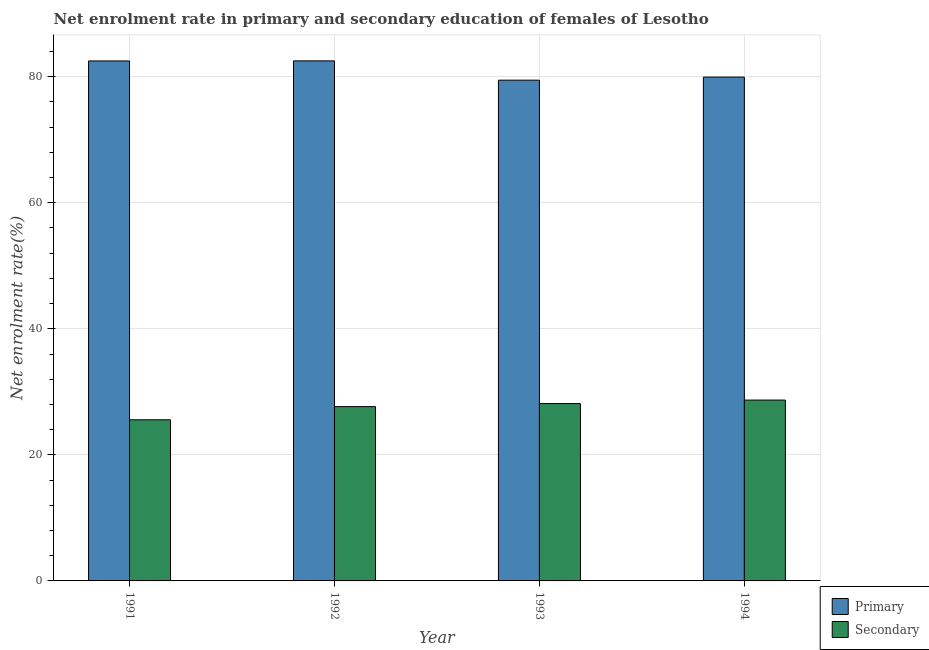How many different coloured bars are there?
Make the answer very short. 2. Are the number of bars per tick equal to the number of legend labels?
Give a very brief answer. Yes. What is the label of the 1st group of bars from the left?
Offer a very short reply. 1991. What is the enrollment rate in primary education in 1992?
Offer a very short reply. 82.52. Across all years, what is the maximum enrollment rate in primary education?
Your response must be concise. 82.52. Across all years, what is the minimum enrollment rate in secondary education?
Offer a very short reply. 25.57. In which year was the enrollment rate in secondary education maximum?
Ensure brevity in your answer.  1994. In which year was the enrollment rate in secondary education minimum?
Ensure brevity in your answer.  1991. What is the total enrollment rate in secondary education in the graph?
Your answer should be compact. 110.06. What is the difference between the enrollment rate in secondary education in 1991 and that in 1993?
Offer a terse response. -2.57. What is the difference between the enrollment rate in primary education in 1991 and the enrollment rate in secondary education in 1992?
Give a very brief answer. -0.01. What is the average enrollment rate in secondary education per year?
Offer a terse response. 27.51. In the year 1994, what is the difference between the enrollment rate in secondary education and enrollment rate in primary education?
Make the answer very short. 0. What is the ratio of the enrollment rate in secondary education in 1992 to that in 1993?
Ensure brevity in your answer.  0.98. Is the enrollment rate in secondary education in 1992 less than that in 1994?
Provide a short and direct response. Yes. Is the difference between the enrollment rate in primary education in 1993 and 1994 greater than the difference between the enrollment rate in secondary education in 1993 and 1994?
Your answer should be very brief. No. What is the difference between the highest and the second highest enrollment rate in secondary education?
Ensure brevity in your answer.  0.56. What is the difference between the highest and the lowest enrollment rate in primary education?
Give a very brief answer. 3.06. In how many years, is the enrollment rate in secondary education greater than the average enrollment rate in secondary education taken over all years?
Provide a short and direct response. 3. What does the 2nd bar from the left in 1993 represents?
Offer a terse response. Secondary. What does the 1st bar from the right in 1991 represents?
Provide a succinct answer. Secondary. How many bars are there?
Provide a short and direct response. 8. Are all the bars in the graph horizontal?
Offer a very short reply. No. How many years are there in the graph?
Provide a succinct answer. 4. What is the difference between two consecutive major ticks on the Y-axis?
Offer a very short reply. 20. Are the values on the major ticks of Y-axis written in scientific E-notation?
Your response must be concise. No. How many legend labels are there?
Provide a short and direct response. 2. How are the legend labels stacked?
Provide a short and direct response. Vertical. What is the title of the graph?
Ensure brevity in your answer.  Net enrolment rate in primary and secondary education of females of Lesotho. Does "Export" appear as one of the legend labels in the graph?
Offer a terse response. No. What is the label or title of the Y-axis?
Provide a short and direct response. Net enrolment rate(%). What is the Net enrolment rate(%) in Primary in 1991?
Provide a short and direct response. 82.51. What is the Net enrolment rate(%) of Secondary in 1991?
Make the answer very short. 25.57. What is the Net enrolment rate(%) of Primary in 1992?
Offer a terse response. 82.52. What is the Net enrolment rate(%) in Secondary in 1992?
Make the answer very short. 27.66. What is the Net enrolment rate(%) of Primary in 1993?
Provide a succinct answer. 79.46. What is the Net enrolment rate(%) of Secondary in 1993?
Provide a short and direct response. 28.14. What is the Net enrolment rate(%) of Primary in 1994?
Provide a succinct answer. 79.94. What is the Net enrolment rate(%) in Secondary in 1994?
Give a very brief answer. 28.7. Across all years, what is the maximum Net enrolment rate(%) of Primary?
Offer a terse response. 82.52. Across all years, what is the maximum Net enrolment rate(%) of Secondary?
Provide a short and direct response. 28.7. Across all years, what is the minimum Net enrolment rate(%) in Primary?
Provide a succinct answer. 79.46. Across all years, what is the minimum Net enrolment rate(%) in Secondary?
Offer a terse response. 25.57. What is the total Net enrolment rate(%) in Primary in the graph?
Provide a short and direct response. 324.42. What is the total Net enrolment rate(%) of Secondary in the graph?
Provide a short and direct response. 110.06. What is the difference between the Net enrolment rate(%) of Primary in 1991 and that in 1992?
Provide a succinct answer. -0.01. What is the difference between the Net enrolment rate(%) of Secondary in 1991 and that in 1992?
Ensure brevity in your answer.  -2.09. What is the difference between the Net enrolment rate(%) of Primary in 1991 and that in 1993?
Make the answer very short. 3.05. What is the difference between the Net enrolment rate(%) in Secondary in 1991 and that in 1993?
Give a very brief answer. -2.57. What is the difference between the Net enrolment rate(%) of Primary in 1991 and that in 1994?
Offer a terse response. 2.56. What is the difference between the Net enrolment rate(%) in Secondary in 1991 and that in 1994?
Offer a very short reply. -3.13. What is the difference between the Net enrolment rate(%) of Primary in 1992 and that in 1993?
Your answer should be compact. 3.06. What is the difference between the Net enrolment rate(%) in Secondary in 1992 and that in 1993?
Your answer should be compact. -0.48. What is the difference between the Net enrolment rate(%) of Primary in 1992 and that in 1994?
Keep it short and to the point. 2.57. What is the difference between the Net enrolment rate(%) of Secondary in 1992 and that in 1994?
Provide a succinct answer. -1.04. What is the difference between the Net enrolment rate(%) of Primary in 1993 and that in 1994?
Ensure brevity in your answer.  -0.49. What is the difference between the Net enrolment rate(%) of Secondary in 1993 and that in 1994?
Keep it short and to the point. -0.56. What is the difference between the Net enrolment rate(%) of Primary in 1991 and the Net enrolment rate(%) of Secondary in 1992?
Ensure brevity in your answer.  54.85. What is the difference between the Net enrolment rate(%) of Primary in 1991 and the Net enrolment rate(%) of Secondary in 1993?
Keep it short and to the point. 54.37. What is the difference between the Net enrolment rate(%) in Primary in 1991 and the Net enrolment rate(%) in Secondary in 1994?
Provide a succinct answer. 53.81. What is the difference between the Net enrolment rate(%) in Primary in 1992 and the Net enrolment rate(%) in Secondary in 1993?
Provide a succinct answer. 54.38. What is the difference between the Net enrolment rate(%) of Primary in 1992 and the Net enrolment rate(%) of Secondary in 1994?
Your response must be concise. 53.82. What is the difference between the Net enrolment rate(%) of Primary in 1993 and the Net enrolment rate(%) of Secondary in 1994?
Offer a very short reply. 50.76. What is the average Net enrolment rate(%) in Primary per year?
Offer a terse response. 81.11. What is the average Net enrolment rate(%) in Secondary per year?
Your response must be concise. 27.51. In the year 1991, what is the difference between the Net enrolment rate(%) in Primary and Net enrolment rate(%) in Secondary?
Provide a succinct answer. 56.94. In the year 1992, what is the difference between the Net enrolment rate(%) in Primary and Net enrolment rate(%) in Secondary?
Keep it short and to the point. 54.86. In the year 1993, what is the difference between the Net enrolment rate(%) of Primary and Net enrolment rate(%) of Secondary?
Keep it short and to the point. 51.32. In the year 1994, what is the difference between the Net enrolment rate(%) of Primary and Net enrolment rate(%) of Secondary?
Offer a very short reply. 51.25. What is the ratio of the Net enrolment rate(%) in Primary in 1991 to that in 1992?
Your answer should be compact. 1. What is the ratio of the Net enrolment rate(%) in Secondary in 1991 to that in 1992?
Offer a terse response. 0.92. What is the ratio of the Net enrolment rate(%) in Primary in 1991 to that in 1993?
Give a very brief answer. 1.04. What is the ratio of the Net enrolment rate(%) of Secondary in 1991 to that in 1993?
Offer a terse response. 0.91. What is the ratio of the Net enrolment rate(%) in Primary in 1991 to that in 1994?
Your answer should be very brief. 1.03. What is the ratio of the Net enrolment rate(%) of Secondary in 1991 to that in 1994?
Provide a short and direct response. 0.89. What is the ratio of the Net enrolment rate(%) in Secondary in 1992 to that in 1993?
Make the answer very short. 0.98. What is the ratio of the Net enrolment rate(%) of Primary in 1992 to that in 1994?
Offer a terse response. 1.03. What is the ratio of the Net enrolment rate(%) of Secondary in 1992 to that in 1994?
Your answer should be very brief. 0.96. What is the ratio of the Net enrolment rate(%) in Secondary in 1993 to that in 1994?
Provide a succinct answer. 0.98. What is the difference between the highest and the second highest Net enrolment rate(%) in Primary?
Make the answer very short. 0.01. What is the difference between the highest and the second highest Net enrolment rate(%) in Secondary?
Your answer should be very brief. 0.56. What is the difference between the highest and the lowest Net enrolment rate(%) in Primary?
Your answer should be compact. 3.06. What is the difference between the highest and the lowest Net enrolment rate(%) of Secondary?
Keep it short and to the point. 3.13. 